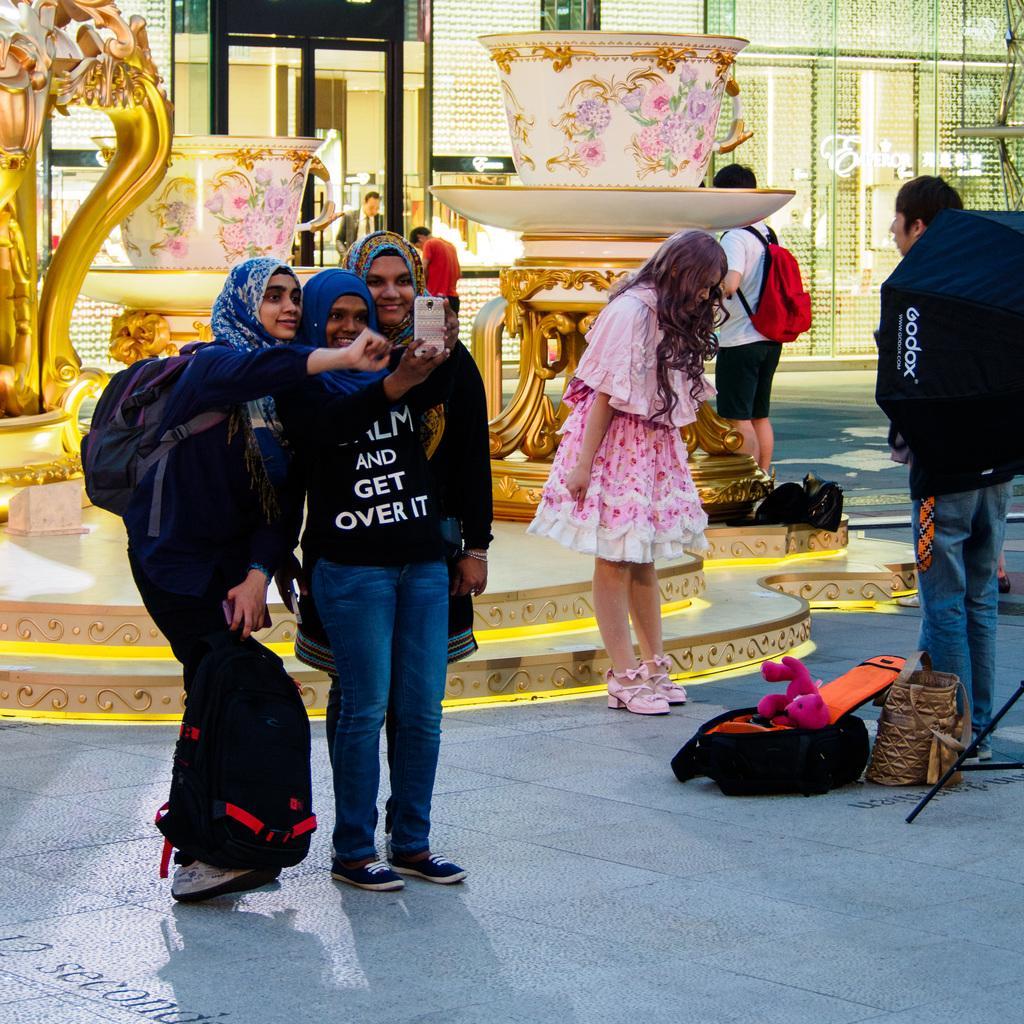Describe this image in one or two sentences. In this image we can see some persons standing near the image of coffee cups and there are some persons taking selfie and there are some persons standing and at the background of the image there is glass door. 